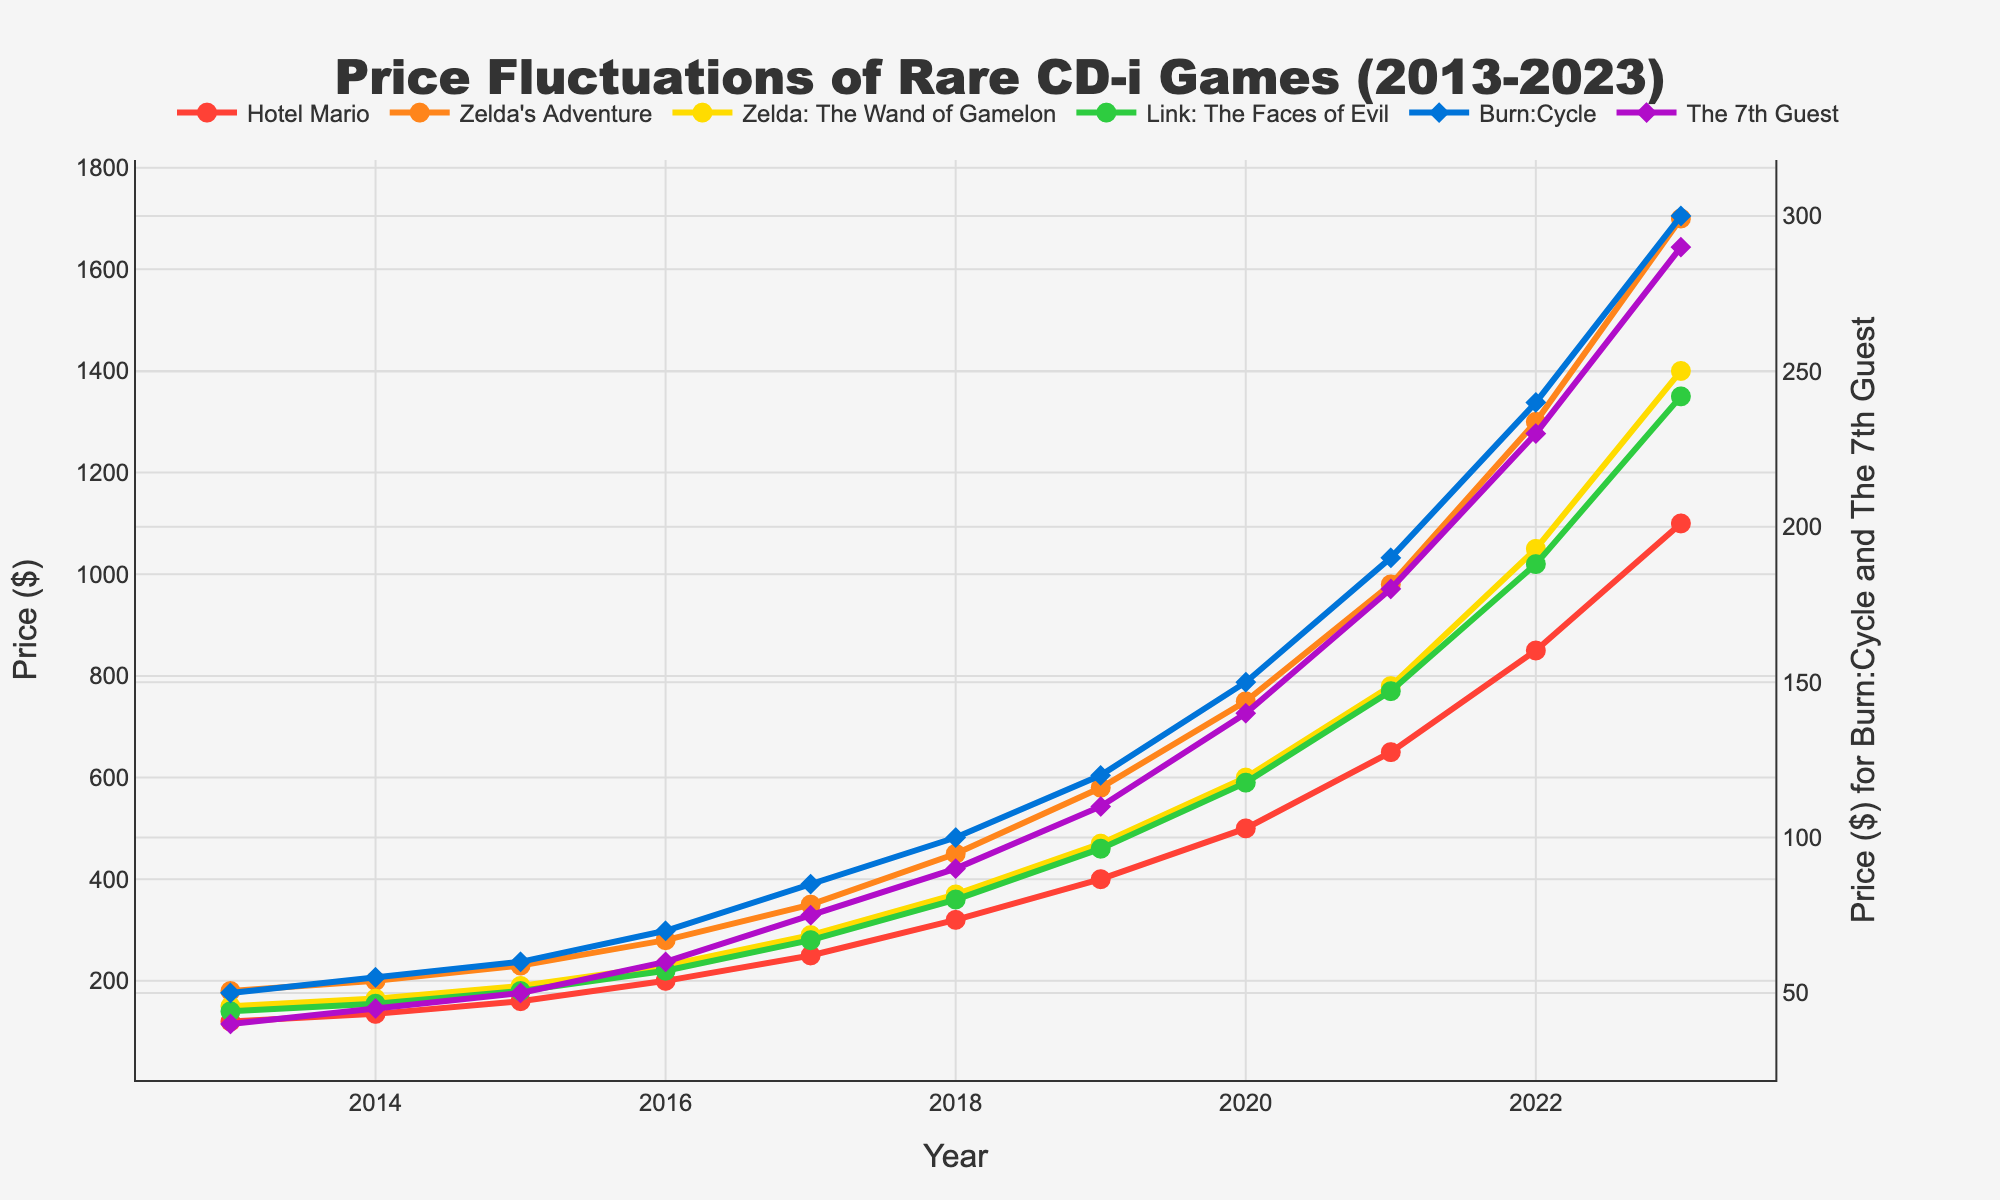Which game had the highest price in 2023? Looking at the figure, the highest price for 2023 is represented by a point at the top of the line. The game corresponding to this line is Zelda's Adventure.
Answer: Zelda's Adventure How did the price of Link: The Faces of Evil change from 2016 to 2018? To find the change, we look at the prices in 2016 and 2018 for Link: The Faces of Evil, which are $220 and $360 respectively. The difference is 360 - 220.
Answer: Increased by $140 Which game had the largest price increase between 2020 and 2023? To determine this, look at the price difference for each game between 2020 and 2023. Zelda's Adventure increased the most from $750 to $1700.
Answer: Zelda's Adventure Is the price trend for The 7th Guest more stable compared to Hotel Mario? By examining the graph, The 7th Guest line seems smoother with smaller increments whereas Hotel Mario line shows steeper increments indicating more volatility.
Answer: Yes In which year did Burn:Cycle surpass the price of $100? Locate the point where Burn:Cycle's price exceeds $100 on the y-axis. This occurs in 2018.
Answer: 2018 Compare the price of Hotel Mario and Zelda: The Wand of Gamelon in 2017. Which one was higher? The figure shows that Hotel Mario was priced at $250 and Zelda: The Wand of Gamelon was at $290 in 2017.
Answer: Zelda: The Wand of Gamelon What is the average price of The 7th Guest over the depicted years? To find this, sum the prices from 2013 to 2023 and divide by the number of years: (40 + 45 + 50 + 60 + 75 + 90 + 110 + 140 + 180 + 230 + 290) / 11.
Answer: Approximately $120.91 Did The 7th Guest ever surpass Burn:Cycle in price, and if so, when? Compare the lines of The 7th Guest and Burn:Cycle. The 7th Guest did surpass Burn:Cycle in price from 2021 onwards.
Answer: Yes, from 2021 onward What was the cumulative price increase for Hotel Mario from 2013 to 2023? The price increased from $120 in 2013 to $1100 in 2023. The cumulative increase is 1100 - 120.
Answer: $980 By what percentage did the price of Zelda's Adventure increase from 2020 to 2023? Calculate the percentage increase from $750 to $1700: ((1700 - 750) / 750) * 100.
Answer: Approximately 126.67% 